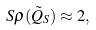Convert formula to latex. <formula><loc_0><loc_0><loc_500><loc_500>S \rho ( \tilde { Q } _ { S } ) \approx 2 ,</formula> 